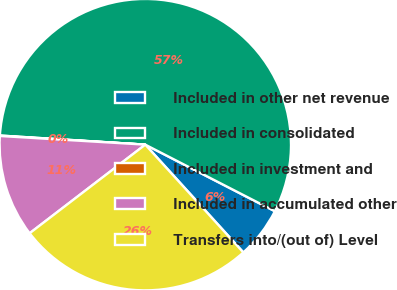Convert chart. <chart><loc_0><loc_0><loc_500><loc_500><pie_chart><fcel>Included in other net revenue<fcel>Included in consolidated<fcel>Included in investment and<fcel>Included in accumulated other<fcel>Transfers into/(out of) Level<nl><fcel>5.7%<fcel>56.55%<fcel>0.05%<fcel>11.35%<fcel>26.34%<nl></chart> 